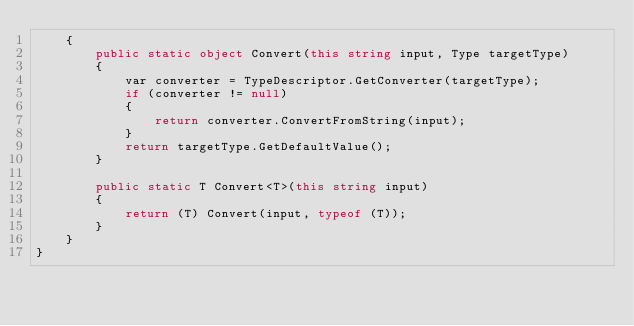Convert code to text. <code><loc_0><loc_0><loc_500><loc_500><_C#_>    {
        public static object Convert(this string input, Type targetType)
        {
            var converter = TypeDescriptor.GetConverter(targetType);
            if (converter != null)
            {
                return converter.ConvertFromString(input);
            }
            return targetType.GetDefaultValue();
        }

        public static T Convert<T>(this string input)
        {
            return (T) Convert(input, typeof (T));
        }
    }
}</code> 